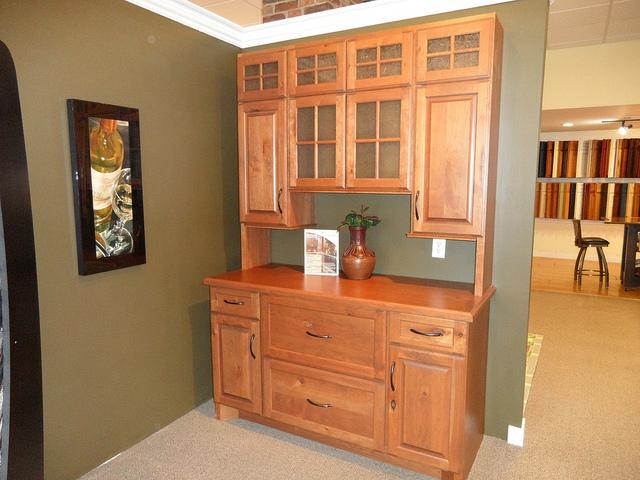How many knobs on the dresser?
Be succinct. 8. How many women are standing there?
Keep it brief. 0. Is this piece of furniture for sale?
Quick response, please. No. Do you see any carpet samples hanging?
Be succinct. Yes. 